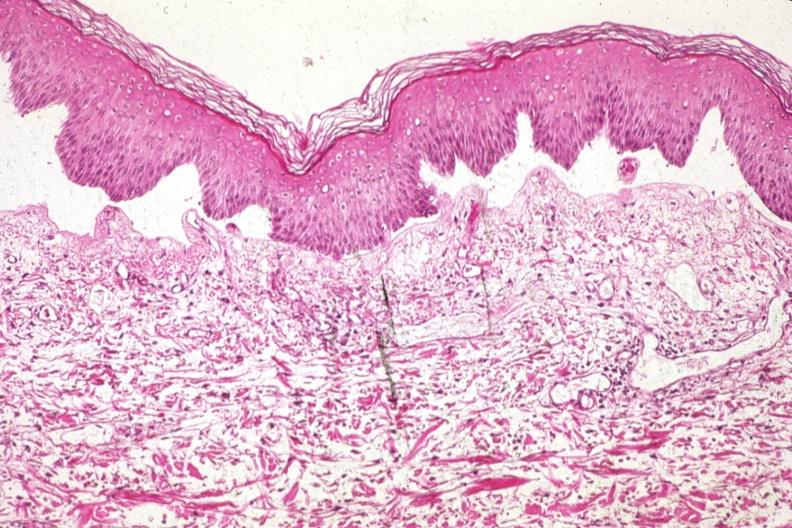does palpable purpura show med excellent example of epidermal separation gross of this lesion is 907?
Answer the question using a single word or phrase. No 